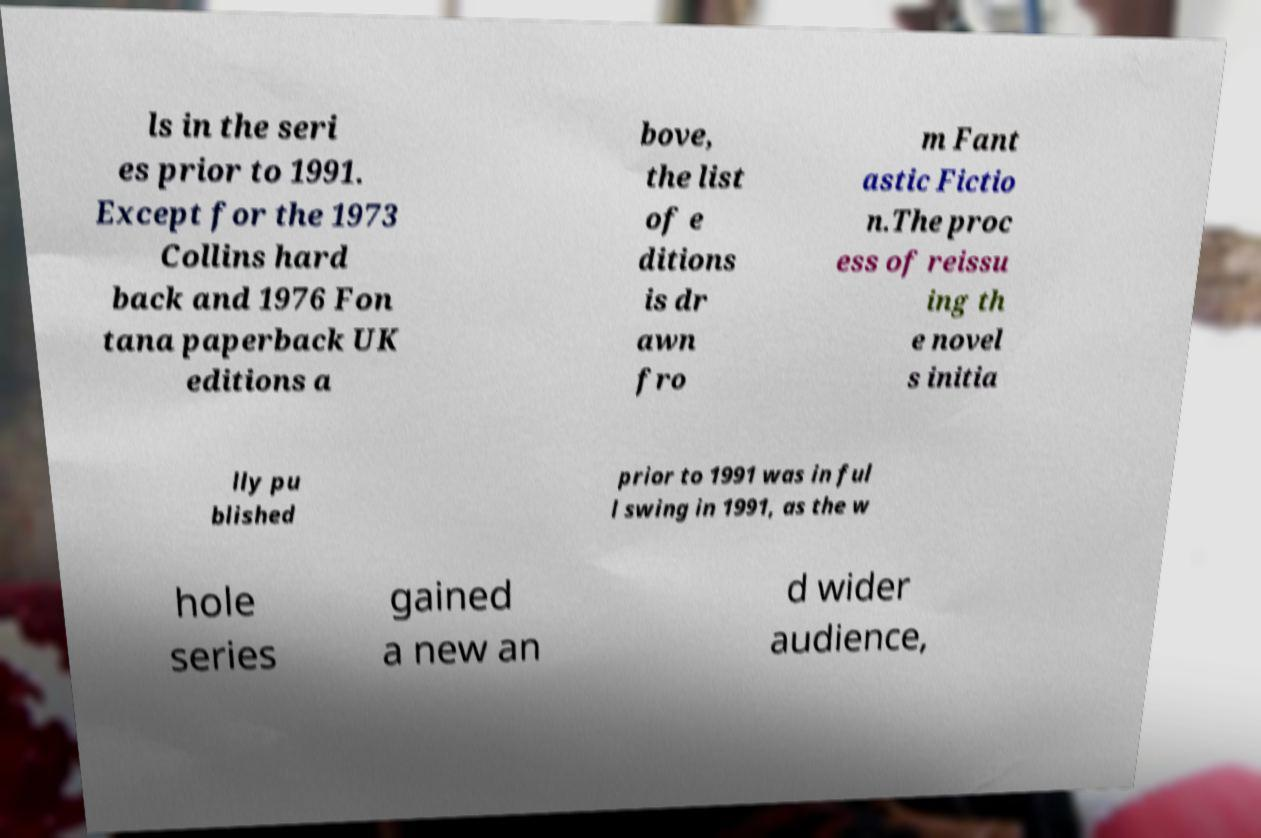Could you extract and type out the text from this image? ls in the seri es prior to 1991. Except for the 1973 Collins hard back and 1976 Fon tana paperback UK editions a bove, the list of e ditions is dr awn fro m Fant astic Fictio n.The proc ess of reissu ing th e novel s initia lly pu blished prior to 1991 was in ful l swing in 1991, as the w hole series gained a new an d wider audience, 